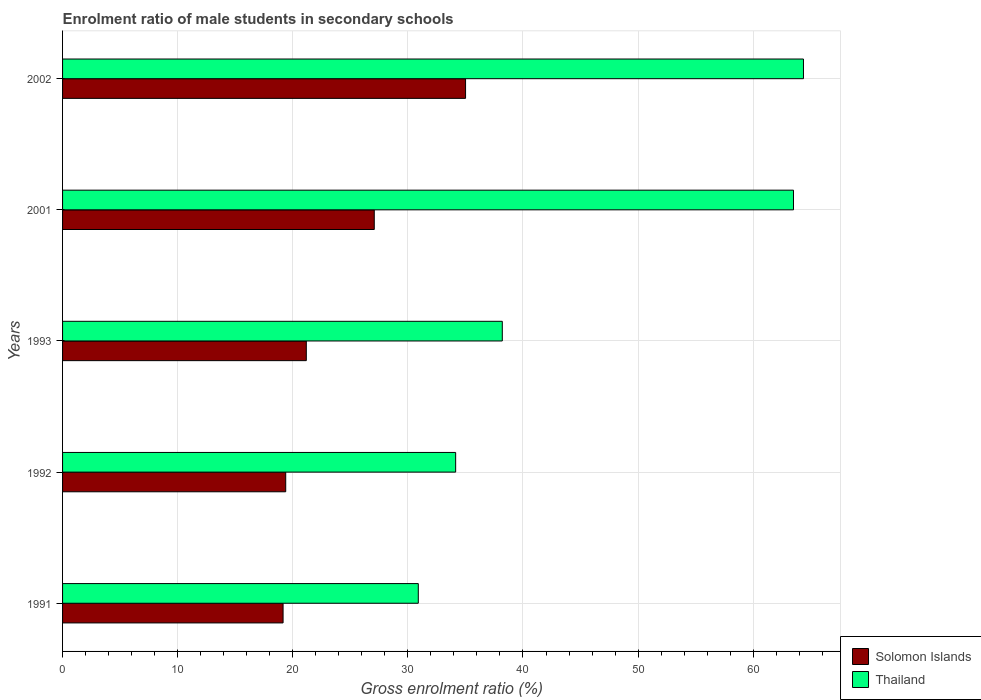How many bars are there on the 3rd tick from the top?
Your answer should be compact. 2. How many bars are there on the 1st tick from the bottom?
Offer a very short reply. 2. What is the label of the 2nd group of bars from the top?
Ensure brevity in your answer.  2001. In how many cases, is the number of bars for a given year not equal to the number of legend labels?
Ensure brevity in your answer.  0. What is the enrolment ratio of male students in secondary schools in Thailand in 1992?
Give a very brief answer. 34.15. Across all years, what is the maximum enrolment ratio of male students in secondary schools in Thailand?
Give a very brief answer. 64.37. Across all years, what is the minimum enrolment ratio of male students in secondary schools in Thailand?
Provide a succinct answer. 30.91. In which year was the enrolment ratio of male students in secondary schools in Thailand maximum?
Your answer should be very brief. 2002. In which year was the enrolment ratio of male students in secondary schools in Solomon Islands minimum?
Provide a succinct answer. 1991. What is the total enrolment ratio of male students in secondary schools in Solomon Islands in the graph?
Give a very brief answer. 121.81. What is the difference between the enrolment ratio of male students in secondary schools in Thailand in 1993 and that in 2002?
Your answer should be compact. -26.17. What is the difference between the enrolment ratio of male students in secondary schools in Thailand in 1993 and the enrolment ratio of male students in secondary schools in Solomon Islands in 1991?
Your answer should be compact. 19.05. What is the average enrolment ratio of male students in secondary schools in Thailand per year?
Your response must be concise. 46.23. In the year 1993, what is the difference between the enrolment ratio of male students in secondary schools in Thailand and enrolment ratio of male students in secondary schools in Solomon Islands?
Ensure brevity in your answer.  17.03. What is the ratio of the enrolment ratio of male students in secondary schools in Thailand in 1991 to that in 2001?
Your answer should be compact. 0.49. Is the difference between the enrolment ratio of male students in secondary schools in Thailand in 1992 and 1993 greater than the difference between the enrolment ratio of male students in secondary schools in Solomon Islands in 1992 and 1993?
Provide a short and direct response. No. What is the difference between the highest and the second highest enrolment ratio of male students in secondary schools in Solomon Islands?
Keep it short and to the point. 7.93. What is the difference between the highest and the lowest enrolment ratio of male students in secondary schools in Thailand?
Give a very brief answer. 33.46. What does the 2nd bar from the top in 1993 represents?
Keep it short and to the point. Solomon Islands. What does the 2nd bar from the bottom in 1991 represents?
Keep it short and to the point. Thailand. How many years are there in the graph?
Provide a short and direct response. 5. Are the values on the major ticks of X-axis written in scientific E-notation?
Ensure brevity in your answer.  No. Does the graph contain any zero values?
Keep it short and to the point. No. Does the graph contain grids?
Provide a succinct answer. Yes. Where does the legend appear in the graph?
Your response must be concise. Bottom right. How many legend labels are there?
Ensure brevity in your answer.  2. How are the legend labels stacked?
Keep it short and to the point. Vertical. What is the title of the graph?
Offer a terse response. Enrolment ratio of male students in secondary schools. What is the label or title of the Y-axis?
Provide a short and direct response. Years. What is the Gross enrolment ratio (%) in Solomon Islands in 1991?
Make the answer very short. 19.16. What is the Gross enrolment ratio (%) in Thailand in 1991?
Your response must be concise. 30.91. What is the Gross enrolment ratio (%) of Solomon Islands in 1992?
Make the answer very short. 19.39. What is the Gross enrolment ratio (%) in Thailand in 1992?
Keep it short and to the point. 34.15. What is the Gross enrolment ratio (%) in Solomon Islands in 1993?
Your response must be concise. 21.18. What is the Gross enrolment ratio (%) of Thailand in 1993?
Make the answer very short. 38.2. What is the Gross enrolment ratio (%) of Solomon Islands in 2001?
Provide a short and direct response. 27.08. What is the Gross enrolment ratio (%) in Thailand in 2001?
Your answer should be compact. 63.5. What is the Gross enrolment ratio (%) in Solomon Islands in 2002?
Provide a succinct answer. 35.01. What is the Gross enrolment ratio (%) of Thailand in 2002?
Your answer should be very brief. 64.37. Across all years, what is the maximum Gross enrolment ratio (%) of Solomon Islands?
Your answer should be compact. 35.01. Across all years, what is the maximum Gross enrolment ratio (%) of Thailand?
Provide a succinct answer. 64.37. Across all years, what is the minimum Gross enrolment ratio (%) in Solomon Islands?
Ensure brevity in your answer.  19.16. Across all years, what is the minimum Gross enrolment ratio (%) of Thailand?
Keep it short and to the point. 30.91. What is the total Gross enrolment ratio (%) of Solomon Islands in the graph?
Offer a terse response. 121.81. What is the total Gross enrolment ratio (%) of Thailand in the graph?
Provide a short and direct response. 231.13. What is the difference between the Gross enrolment ratio (%) in Solomon Islands in 1991 and that in 1992?
Provide a short and direct response. -0.23. What is the difference between the Gross enrolment ratio (%) in Thailand in 1991 and that in 1992?
Your response must be concise. -3.25. What is the difference between the Gross enrolment ratio (%) of Solomon Islands in 1991 and that in 1993?
Your answer should be very brief. -2.02. What is the difference between the Gross enrolment ratio (%) in Thailand in 1991 and that in 1993?
Give a very brief answer. -7.3. What is the difference between the Gross enrolment ratio (%) of Solomon Islands in 1991 and that in 2001?
Your answer should be very brief. -7.92. What is the difference between the Gross enrolment ratio (%) of Thailand in 1991 and that in 2001?
Make the answer very short. -32.6. What is the difference between the Gross enrolment ratio (%) in Solomon Islands in 1991 and that in 2002?
Provide a short and direct response. -15.85. What is the difference between the Gross enrolment ratio (%) of Thailand in 1991 and that in 2002?
Provide a succinct answer. -33.46. What is the difference between the Gross enrolment ratio (%) in Solomon Islands in 1992 and that in 1993?
Your answer should be compact. -1.79. What is the difference between the Gross enrolment ratio (%) of Thailand in 1992 and that in 1993?
Your response must be concise. -4.05. What is the difference between the Gross enrolment ratio (%) of Solomon Islands in 1992 and that in 2001?
Provide a succinct answer. -7.69. What is the difference between the Gross enrolment ratio (%) of Thailand in 1992 and that in 2001?
Your response must be concise. -29.35. What is the difference between the Gross enrolment ratio (%) of Solomon Islands in 1992 and that in 2002?
Your response must be concise. -15.62. What is the difference between the Gross enrolment ratio (%) of Thailand in 1992 and that in 2002?
Your response must be concise. -30.22. What is the difference between the Gross enrolment ratio (%) in Solomon Islands in 1993 and that in 2001?
Provide a succinct answer. -5.9. What is the difference between the Gross enrolment ratio (%) in Thailand in 1993 and that in 2001?
Your answer should be compact. -25.3. What is the difference between the Gross enrolment ratio (%) of Solomon Islands in 1993 and that in 2002?
Provide a succinct answer. -13.84. What is the difference between the Gross enrolment ratio (%) in Thailand in 1993 and that in 2002?
Provide a succinct answer. -26.17. What is the difference between the Gross enrolment ratio (%) of Solomon Islands in 2001 and that in 2002?
Make the answer very short. -7.93. What is the difference between the Gross enrolment ratio (%) of Thailand in 2001 and that in 2002?
Your answer should be compact. -0.87. What is the difference between the Gross enrolment ratio (%) in Solomon Islands in 1991 and the Gross enrolment ratio (%) in Thailand in 1992?
Ensure brevity in your answer.  -14.99. What is the difference between the Gross enrolment ratio (%) of Solomon Islands in 1991 and the Gross enrolment ratio (%) of Thailand in 1993?
Your response must be concise. -19.05. What is the difference between the Gross enrolment ratio (%) in Solomon Islands in 1991 and the Gross enrolment ratio (%) in Thailand in 2001?
Offer a terse response. -44.34. What is the difference between the Gross enrolment ratio (%) in Solomon Islands in 1991 and the Gross enrolment ratio (%) in Thailand in 2002?
Ensure brevity in your answer.  -45.21. What is the difference between the Gross enrolment ratio (%) in Solomon Islands in 1992 and the Gross enrolment ratio (%) in Thailand in 1993?
Offer a terse response. -18.82. What is the difference between the Gross enrolment ratio (%) of Solomon Islands in 1992 and the Gross enrolment ratio (%) of Thailand in 2001?
Offer a very short reply. -44.11. What is the difference between the Gross enrolment ratio (%) in Solomon Islands in 1992 and the Gross enrolment ratio (%) in Thailand in 2002?
Provide a succinct answer. -44.98. What is the difference between the Gross enrolment ratio (%) in Solomon Islands in 1993 and the Gross enrolment ratio (%) in Thailand in 2001?
Ensure brevity in your answer.  -42.33. What is the difference between the Gross enrolment ratio (%) in Solomon Islands in 1993 and the Gross enrolment ratio (%) in Thailand in 2002?
Provide a succinct answer. -43.19. What is the difference between the Gross enrolment ratio (%) of Solomon Islands in 2001 and the Gross enrolment ratio (%) of Thailand in 2002?
Offer a terse response. -37.29. What is the average Gross enrolment ratio (%) of Solomon Islands per year?
Provide a succinct answer. 24.36. What is the average Gross enrolment ratio (%) in Thailand per year?
Give a very brief answer. 46.23. In the year 1991, what is the difference between the Gross enrolment ratio (%) of Solomon Islands and Gross enrolment ratio (%) of Thailand?
Your answer should be compact. -11.75. In the year 1992, what is the difference between the Gross enrolment ratio (%) of Solomon Islands and Gross enrolment ratio (%) of Thailand?
Your answer should be compact. -14.76. In the year 1993, what is the difference between the Gross enrolment ratio (%) of Solomon Islands and Gross enrolment ratio (%) of Thailand?
Your answer should be compact. -17.03. In the year 2001, what is the difference between the Gross enrolment ratio (%) in Solomon Islands and Gross enrolment ratio (%) in Thailand?
Keep it short and to the point. -36.42. In the year 2002, what is the difference between the Gross enrolment ratio (%) in Solomon Islands and Gross enrolment ratio (%) in Thailand?
Offer a very short reply. -29.36. What is the ratio of the Gross enrolment ratio (%) of Thailand in 1991 to that in 1992?
Offer a terse response. 0.9. What is the ratio of the Gross enrolment ratio (%) of Solomon Islands in 1991 to that in 1993?
Ensure brevity in your answer.  0.9. What is the ratio of the Gross enrolment ratio (%) in Thailand in 1991 to that in 1993?
Offer a very short reply. 0.81. What is the ratio of the Gross enrolment ratio (%) of Solomon Islands in 1991 to that in 2001?
Your response must be concise. 0.71. What is the ratio of the Gross enrolment ratio (%) of Thailand in 1991 to that in 2001?
Keep it short and to the point. 0.49. What is the ratio of the Gross enrolment ratio (%) of Solomon Islands in 1991 to that in 2002?
Ensure brevity in your answer.  0.55. What is the ratio of the Gross enrolment ratio (%) of Thailand in 1991 to that in 2002?
Your answer should be compact. 0.48. What is the ratio of the Gross enrolment ratio (%) of Solomon Islands in 1992 to that in 1993?
Your answer should be very brief. 0.92. What is the ratio of the Gross enrolment ratio (%) of Thailand in 1992 to that in 1993?
Offer a terse response. 0.89. What is the ratio of the Gross enrolment ratio (%) in Solomon Islands in 1992 to that in 2001?
Keep it short and to the point. 0.72. What is the ratio of the Gross enrolment ratio (%) in Thailand in 1992 to that in 2001?
Provide a short and direct response. 0.54. What is the ratio of the Gross enrolment ratio (%) in Solomon Islands in 1992 to that in 2002?
Keep it short and to the point. 0.55. What is the ratio of the Gross enrolment ratio (%) in Thailand in 1992 to that in 2002?
Make the answer very short. 0.53. What is the ratio of the Gross enrolment ratio (%) of Solomon Islands in 1993 to that in 2001?
Your answer should be compact. 0.78. What is the ratio of the Gross enrolment ratio (%) of Thailand in 1993 to that in 2001?
Provide a succinct answer. 0.6. What is the ratio of the Gross enrolment ratio (%) of Solomon Islands in 1993 to that in 2002?
Provide a succinct answer. 0.6. What is the ratio of the Gross enrolment ratio (%) of Thailand in 1993 to that in 2002?
Provide a short and direct response. 0.59. What is the ratio of the Gross enrolment ratio (%) of Solomon Islands in 2001 to that in 2002?
Provide a succinct answer. 0.77. What is the ratio of the Gross enrolment ratio (%) in Thailand in 2001 to that in 2002?
Your answer should be very brief. 0.99. What is the difference between the highest and the second highest Gross enrolment ratio (%) of Solomon Islands?
Your answer should be compact. 7.93. What is the difference between the highest and the second highest Gross enrolment ratio (%) in Thailand?
Give a very brief answer. 0.87. What is the difference between the highest and the lowest Gross enrolment ratio (%) in Solomon Islands?
Your answer should be compact. 15.85. What is the difference between the highest and the lowest Gross enrolment ratio (%) of Thailand?
Your answer should be very brief. 33.46. 